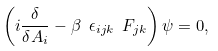Convert formula to latex. <formula><loc_0><loc_0><loc_500><loc_500>\left ( i \frac { \delta } { \delta A _ { i } } - \beta \ \epsilon _ { i j k } \ F _ { j k } \right ) \psi = 0 ,</formula> 